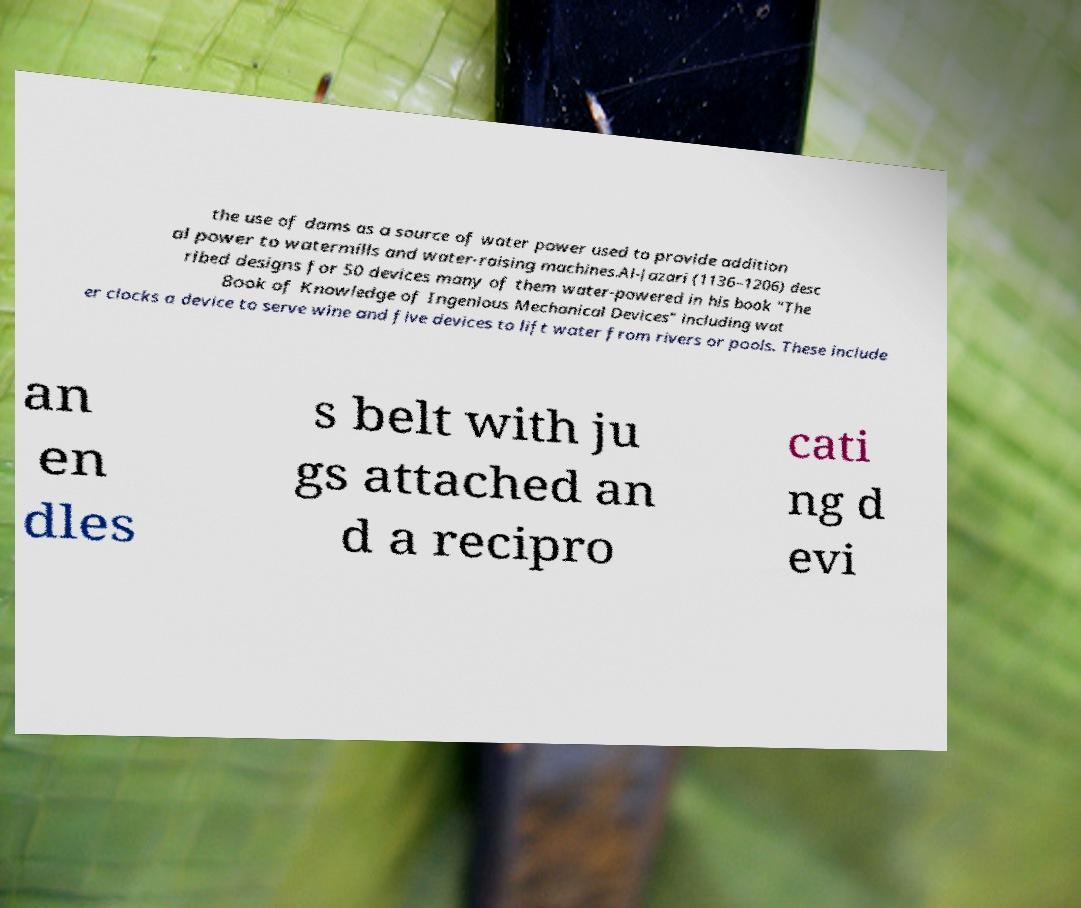Please read and relay the text visible in this image. What does it say? the use of dams as a source of water power used to provide addition al power to watermills and water-raising machines.Al-Jazari (1136–1206) desc ribed designs for 50 devices many of them water-powered in his book "The Book of Knowledge of Ingenious Mechanical Devices" including wat er clocks a device to serve wine and five devices to lift water from rivers or pools. These include an en dles s belt with ju gs attached an d a recipro cati ng d evi 